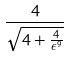Convert formula to latex. <formula><loc_0><loc_0><loc_500><loc_500>\frac { 4 } { \sqrt { 4 + \frac { 4 } { \epsilon ^ { 9 } } } }</formula> 